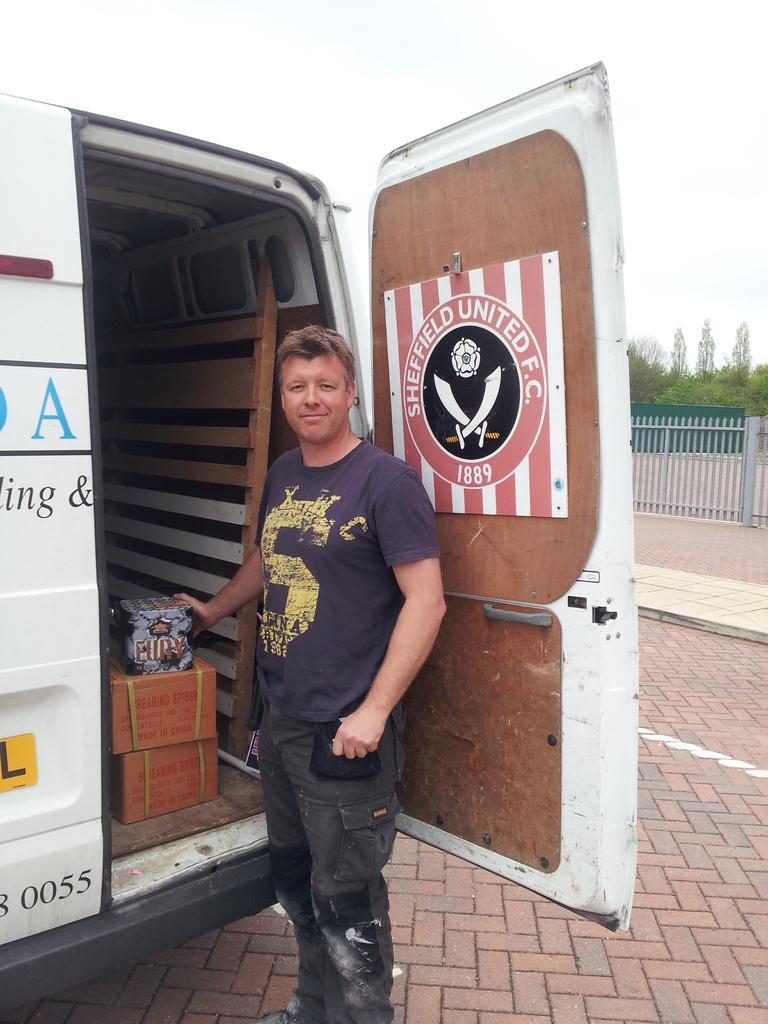Describe this image in one or two sentences. In the center of the image we can see a man standing. On the left there is a truck and there are boxes in the truck. On the right there is a fence and trees. At the top there is sky. 